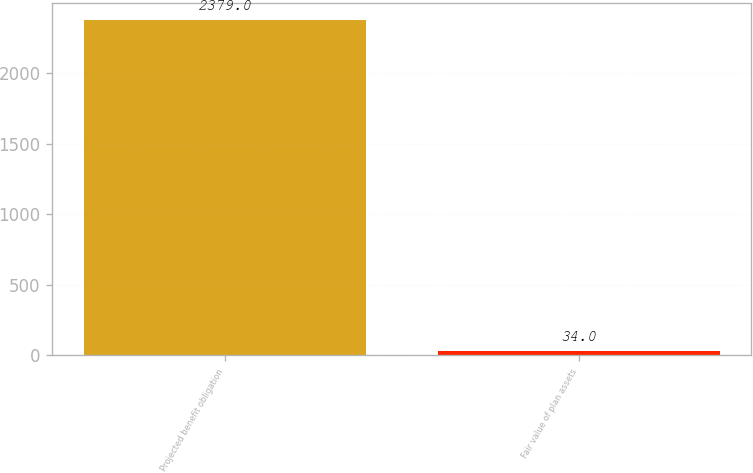Convert chart. <chart><loc_0><loc_0><loc_500><loc_500><bar_chart><fcel>Projected benefit obligation<fcel>Fair value of plan assets<nl><fcel>2379<fcel>34<nl></chart> 